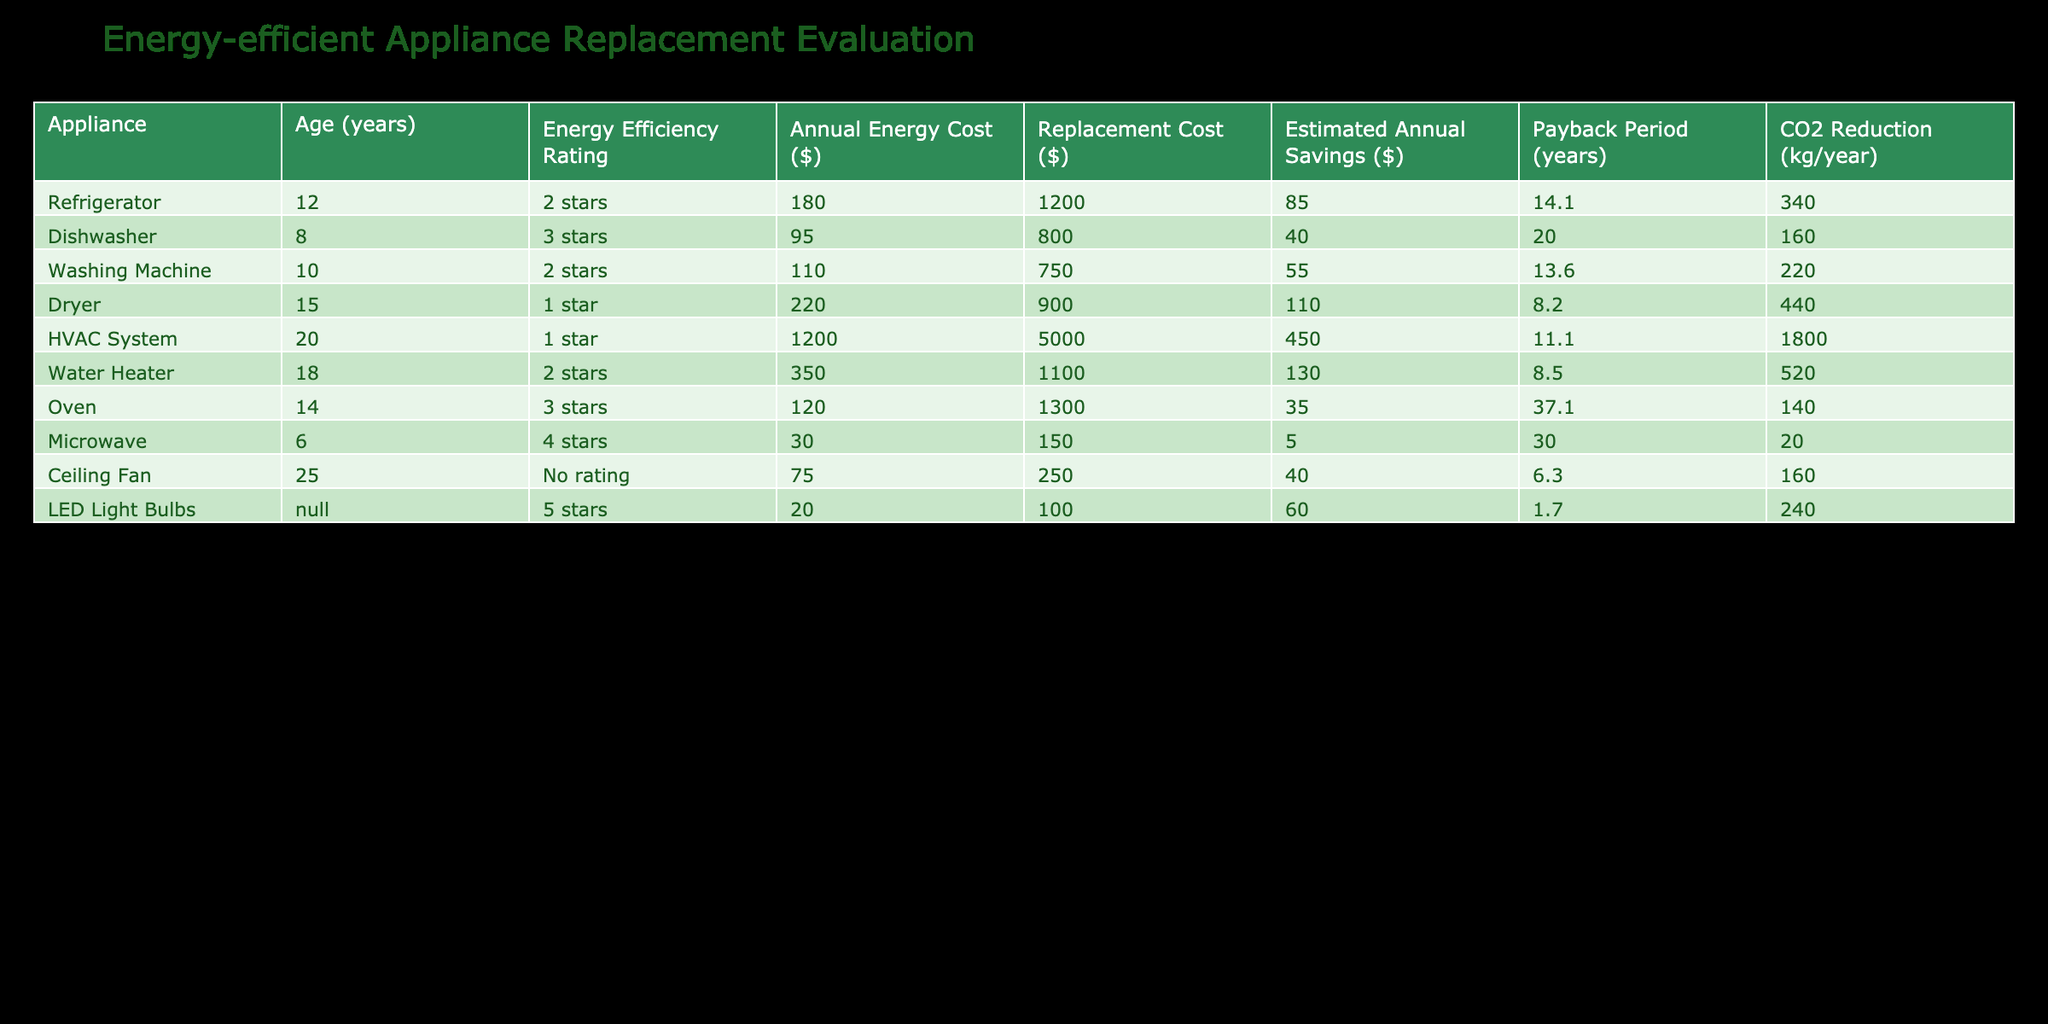What is the annual energy cost of the HVAC system? The HVAC system has an entry in the table indicating its annual energy cost, which is provided directly as $1200.
Answer: 1200 Which appliance has the highest estimated annual savings? By reviewing the estimated annual savings column, the HVAC system shows the highest savings of $450 compared to others.
Answer: HVAC System What is the payback period for replacing the dryer? The payback period is directly listed in the table for the dryer, which is 8.2 years.
Answer: 8.2 Is the water heater more energy-efficient than the refrigerator? The refrigerator has a rating of 2 stars, while the water heater also has a 2-star rating. Since they have the same rating, they are equally energy-efficient.
Answer: No Calculate the total estimated annual savings for appliances rated 3 stars or higher. The dishwasher saves $40, the oven saves $35, and the microwave saves $5. Adding these gives a total savings of $40 + $35 + $5 = $80.
Answer: 80 Which appliance contributes the most to CO2 reduction? The CO2 reduction for each appliance is listed, and the HVAC system contributes the most with a reduction of 1800 kg/year.
Answer: HVAC System What is the average annual energy cost of the appliances listed? Adding the annual energy costs (180 + 95 + 110 + 220 + 1200 + 350 + 120 + 30 + 75 + 20) gives a total of 2280, divided by 10 appliances results in an average of 228.
Answer: 228 Does the LED light bulb have the lowest annual energy cost? The yearly cost for the LED light bulbs is $20, and this is the lowest when compared to all other appliances listed.
Answer: Yes Which appliance would have the shortest payback period if replaced? The payback period can be found in the table; the ceiling fan shows the shortest period of 6.3 years compared to others.
Answer: Ceiling Fan 